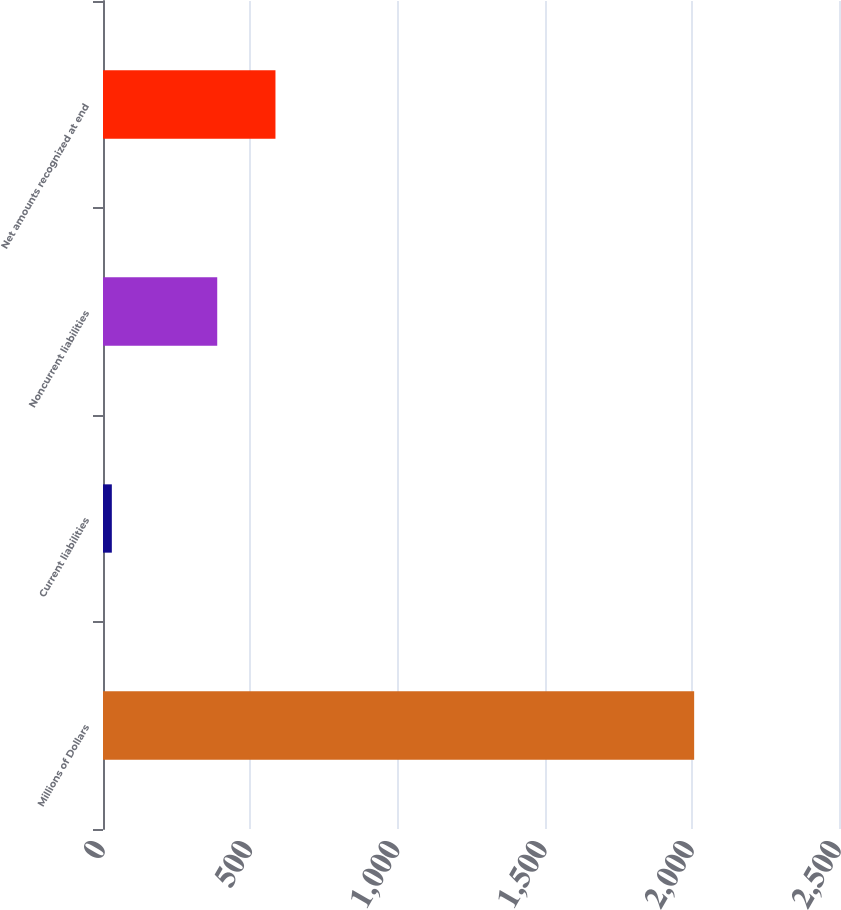Convert chart. <chart><loc_0><loc_0><loc_500><loc_500><bar_chart><fcel>Millions of Dollars<fcel>Current liabilities<fcel>Noncurrent liabilities<fcel>Net amounts recognized at end<nl><fcel>2008<fcel>30<fcel>388<fcel>585.8<nl></chart> 